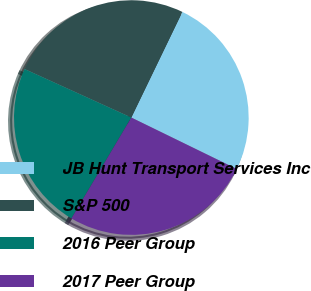Convert chart. <chart><loc_0><loc_0><loc_500><loc_500><pie_chart><fcel>JB Hunt Transport Services Inc<fcel>S&P 500<fcel>2016 Peer Group<fcel>2017 Peer Group<nl><fcel>25.06%<fcel>25.37%<fcel>23.26%<fcel>26.3%<nl></chart> 